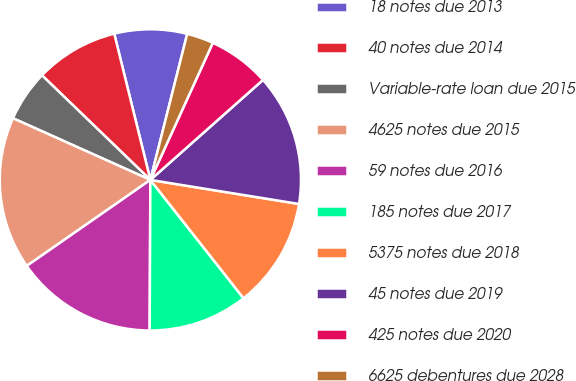Convert chart. <chart><loc_0><loc_0><loc_500><loc_500><pie_chart><fcel>18 notes due 2013<fcel>40 notes due 2014<fcel>Variable-rate loan due 2015<fcel>4625 notes due 2015<fcel>59 notes due 2016<fcel>185 notes due 2017<fcel>5375 notes due 2018<fcel>45 notes due 2019<fcel>425 notes due 2020<fcel>6625 debentures due 2028<nl><fcel>7.79%<fcel>8.93%<fcel>5.5%<fcel>16.39%<fcel>15.25%<fcel>10.69%<fcel>11.83%<fcel>14.11%<fcel>6.64%<fcel>2.87%<nl></chart> 